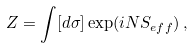<formula> <loc_0><loc_0><loc_500><loc_500>Z = \int [ d \sigma ] \exp ( i N S _ { e f f } ) \, ,</formula> 